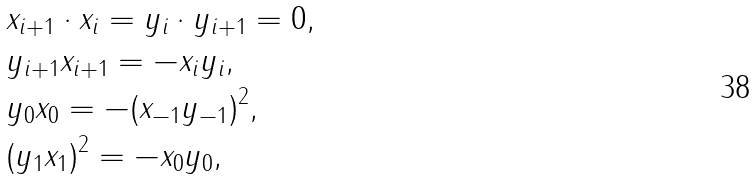Convert formula to latex. <formula><loc_0><loc_0><loc_500><loc_500>& x _ { i + 1 } \cdot x _ { i } = y _ { i } \cdot y _ { i + 1 } = 0 , \\ & y _ { i + 1 } x _ { i + 1 } = - x _ { i } y _ { i } , \\ & y _ { 0 } x _ { 0 } = - ( x _ { - 1 } y _ { - 1 } ) ^ { 2 } , \\ & ( y _ { 1 } x _ { 1 } ) ^ { 2 } = - x _ { 0 } y _ { 0 } ,</formula> 